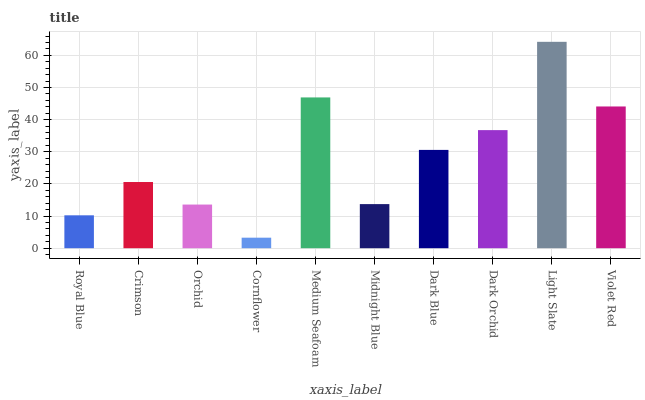Is Cornflower the minimum?
Answer yes or no. Yes. Is Light Slate the maximum?
Answer yes or no. Yes. Is Crimson the minimum?
Answer yes or no. No. Is Crimson the maximum?
Answer yes or no. No. Is Crimson greater than Royal Blue?
Answer yes or no. Yes. Is Royal Blue less than Crimson?
Answer yes or no. Yes. Is Royal Blue greater than Crimson?
Answer yes or no. No. Is Crimson less than Royal Blue?
Answer yes or no. No. Is Dark Blue the high median?
Answer yes or no. Yes. Is Crimson the low median?
Answer yes or no. Yes. Is Light Slate the high median?
Answer yes or no. No. Is Royal Blue the low median?
Answer yes or no. No. 